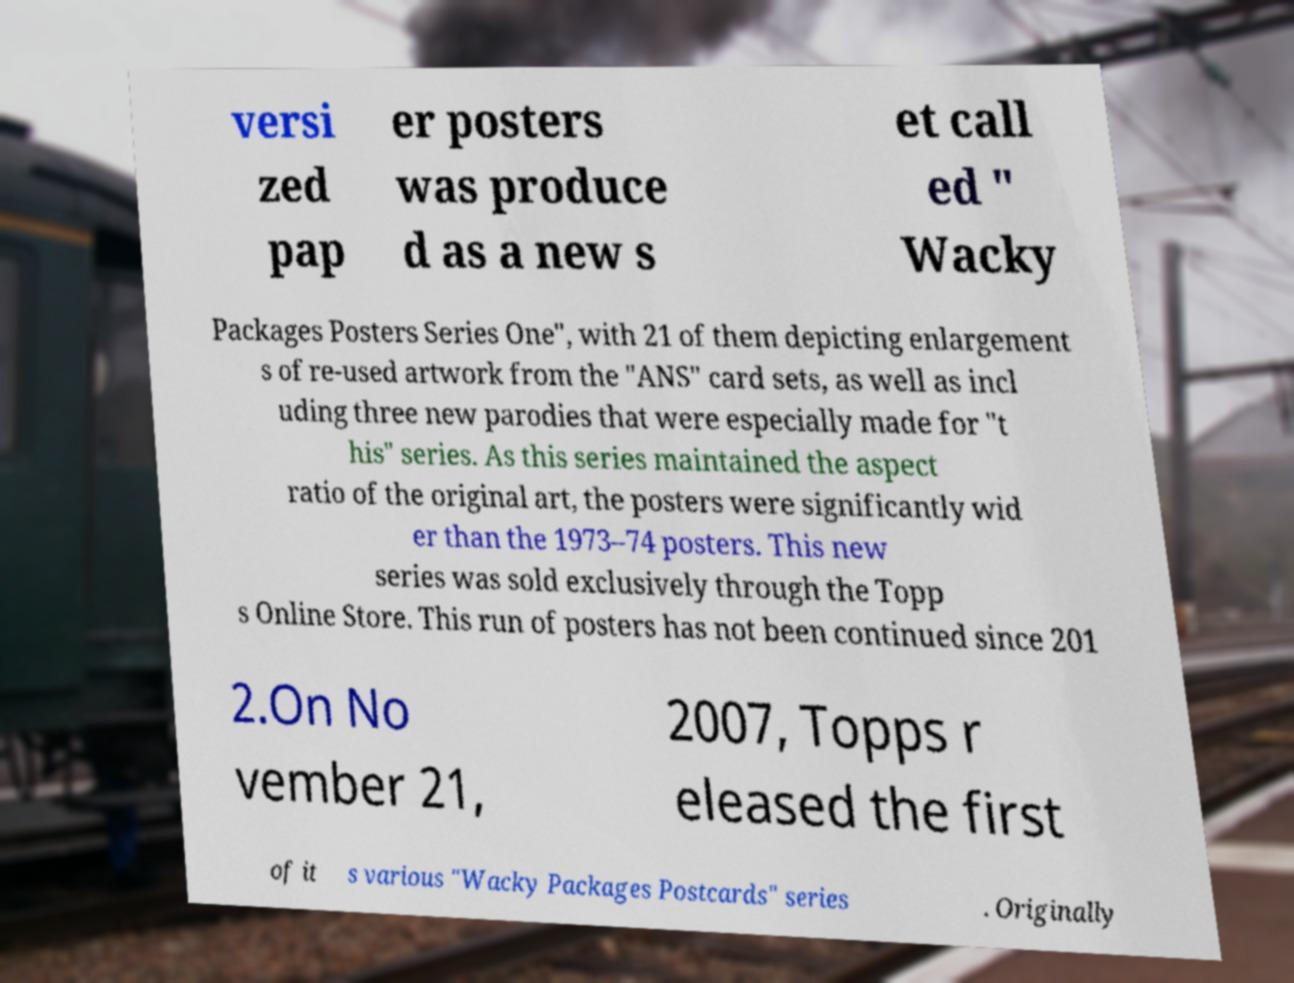There's text embedded in this image that I need extracted. Can you transcribe it verbatim? versi zed pap er posters was produce d as a new s et call ed " Wacky Packages Posters Series One", with 21 of them depicting enlargement s of re-used artwork from the "ANS" card sets, as well as incl uding three new parodies that were especially made for "t his" series. As this series maintained the aspect ratio of the original art, the posters were significantly wid er than the 1973–74 posters. This new series was sold exclusively through the Topp s Online Store. This run of posters has not been continued since 201 2.On No vember 21, 2007, Topps r eleased the first of it s various "Wacky Packages Postcards" series . Originally 